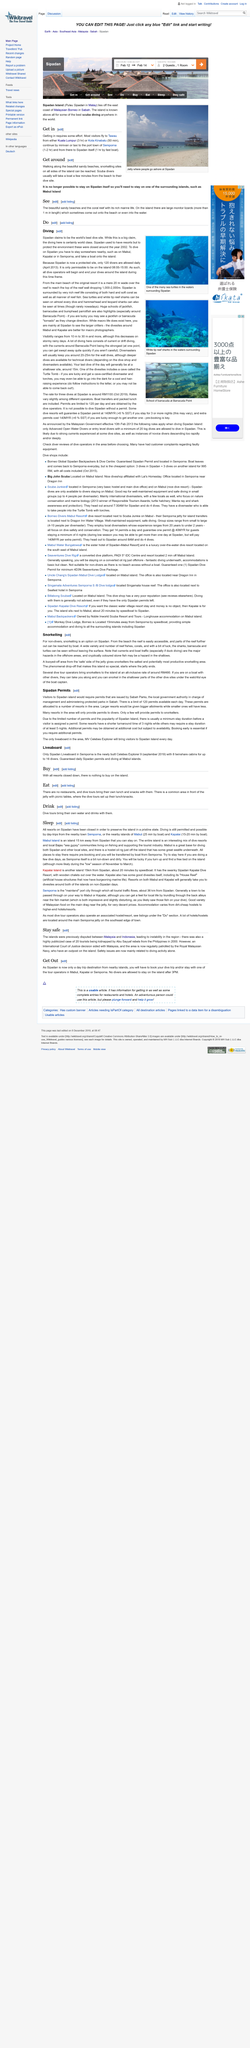Mention a couple of crucial points in this snapshot. The Royal Malaysian Navy regularly patrols the islands. Sipadan Island allows a maximum of 120 divers to enter its waters daily. The hazards listed include boat traffic and currents in the offshore areas, as well as the presence of cryptically colored stone fish in the shallow waters. When snorkelling at Sipadan, one is likely to encounter a diverse range of reef fish, corals, and potentially sharks, barracuda, and turtles, as it offers a unique opportunity to observe wildlife in its natural habitat. The topic of this page is "sleep. 